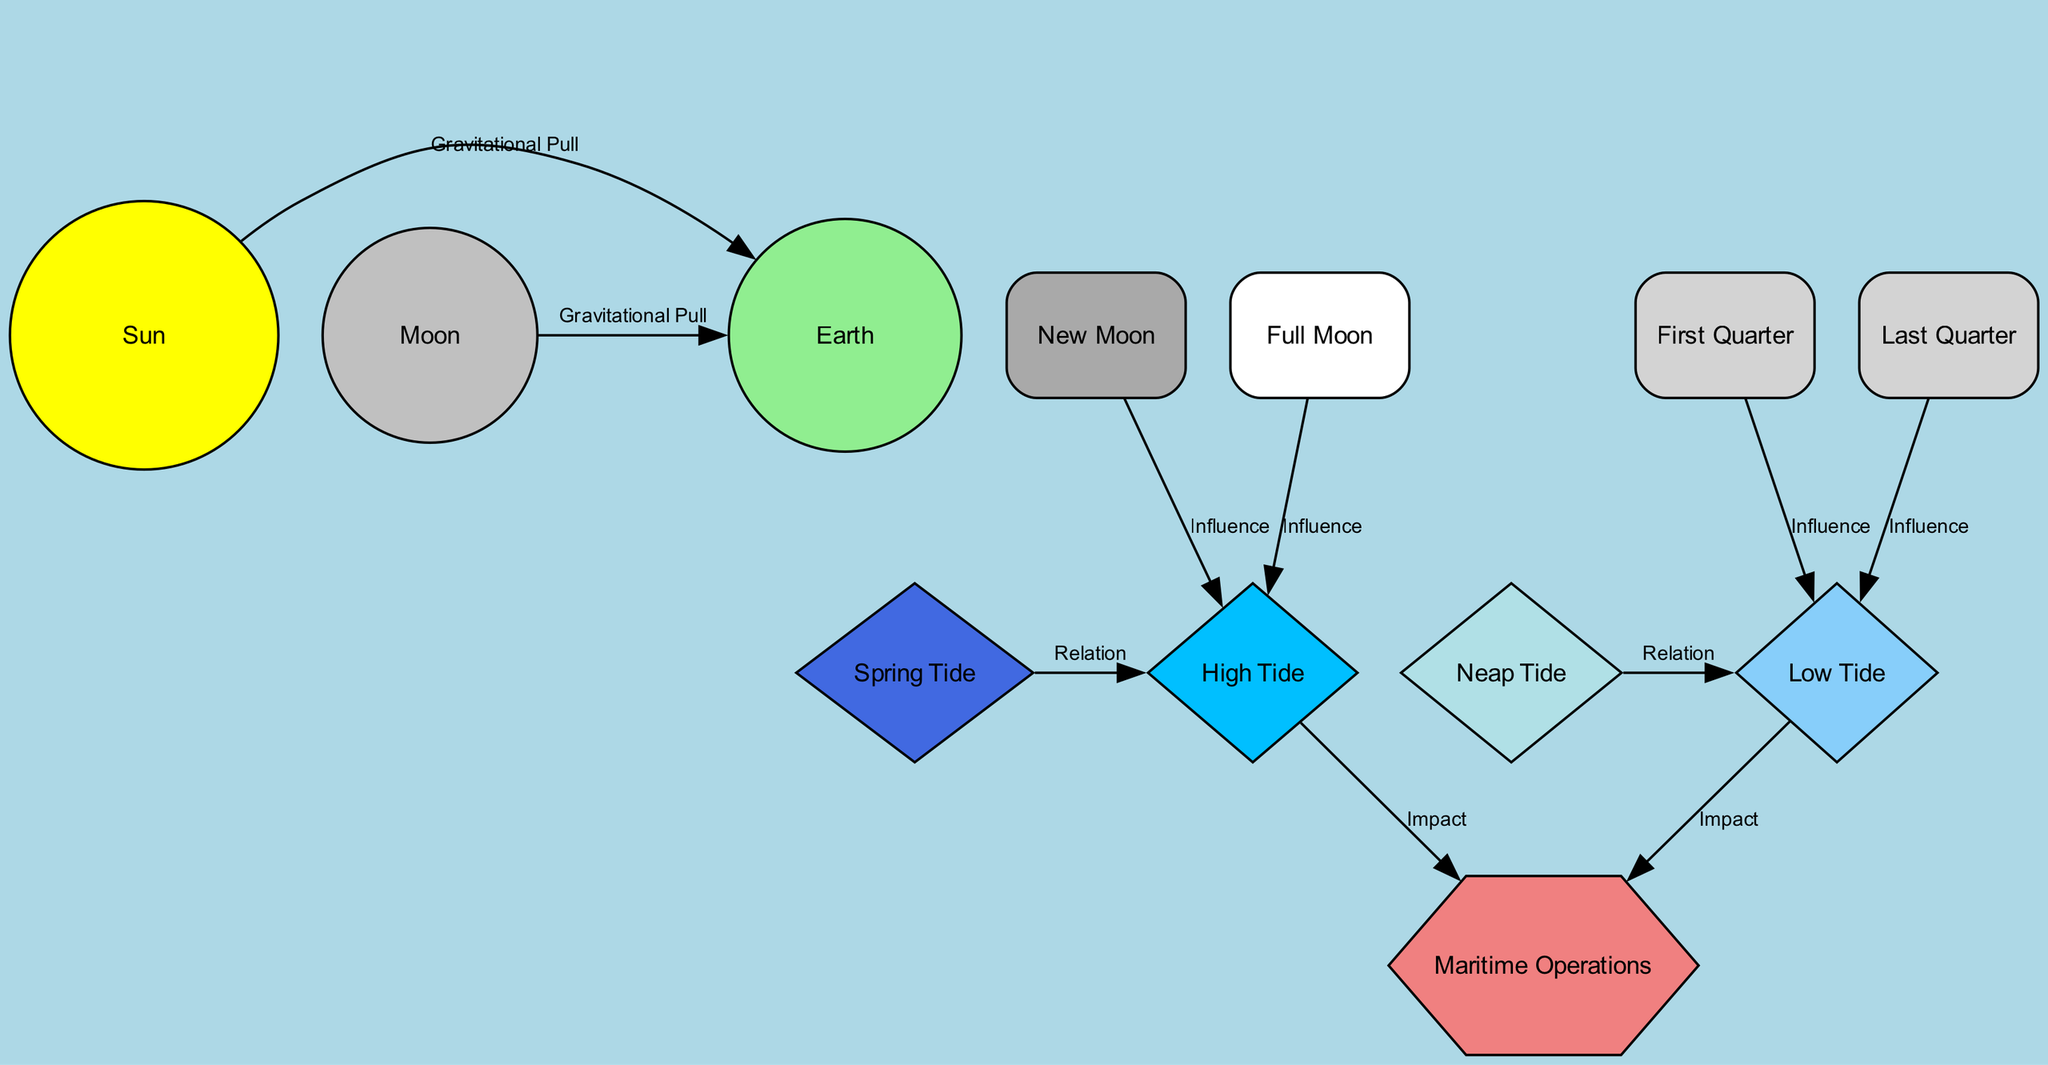What is the main body causing tidal changes? The primary body affecting tides is the Moon, as indicated in the nodes section of the diagram, where it is explicitly labeled and described.
Answer: Moon Which phase causes the highest tidal range? The diagram shows that Spring Tide occurs during Full and New Moons, leading to the largest tidal range, as highlighted in the relations between the nodes.
Answer: Spring Tide How many phases of the Moon are depicted in the diagram? The diagram presents four distinct Moon phases: New Moon, Full Moon, First Quarter, and Last Quarter, which can be counted directly from the nodes section.
Answer: Four What influences High Tide according to the diagram? High Tide is influenced by both New Moon and Full Moon phases, as shown in the edges segment that connects these phases to High Tide with a labeled influence.
Answer: New Moon and Full Moon What is the impact of Low Tide on Maritime Operations? The diagram states that Low Tide impacts vessel buoyancy and approach routes, indicated by the edge connecting Low Tide to Maritime Operations with an associated impact description.
Answer: Vessel buoyancy and approach routes What is the relationship between Neap Tide and Low Tide? Neap Tide relates to Low Tide by producing the lowest range of tidal variation, as specified in the edge connected between these two nodes.
Answer: Produces the lowest range of tidal variation Which celestial body provides the gravitational pull that affects tides alongside the Moon? The diagram indicates that the Sun also provides a gravitational pull influencing tides, as described in the edges connecting both the Sun and Moon to the Earth.
Answer: Sun What occurs at First Quarter in terms of sea levels? The diagram indicates that during First Quarter, moderate tides occur, which involves analyzing the relationship from the First Quarter node to Low Tide.
Answer: Moderate tides How does the Full Moon impact tides? The diagram illustrates that Full Moon influences High Tide, leading to higher than normal tides, as described by the edge directed from the Full Moon to High Tide.
Answer: Higher than normal tides 